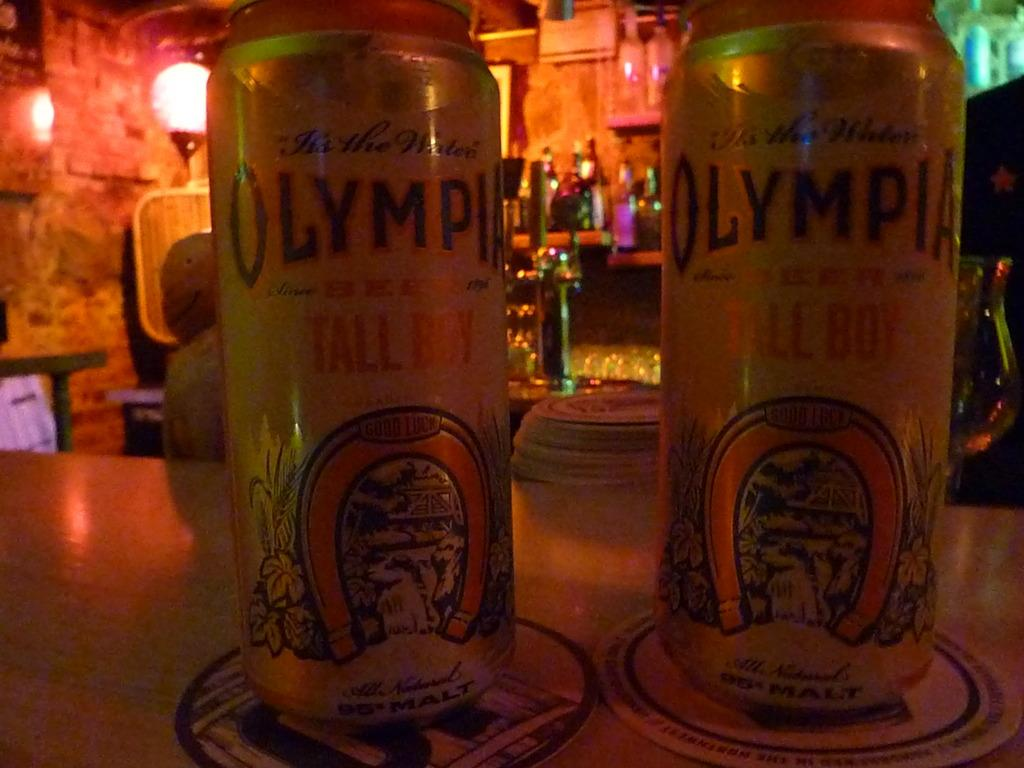<image>
Give a short and clear explanation of the subsequent image. Two cans of Olympia beer sit side by side on coasters in a bar. 